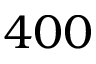<formula> <loc_0><loc_0><loc_500><loc_500>4 0 0</formula> 